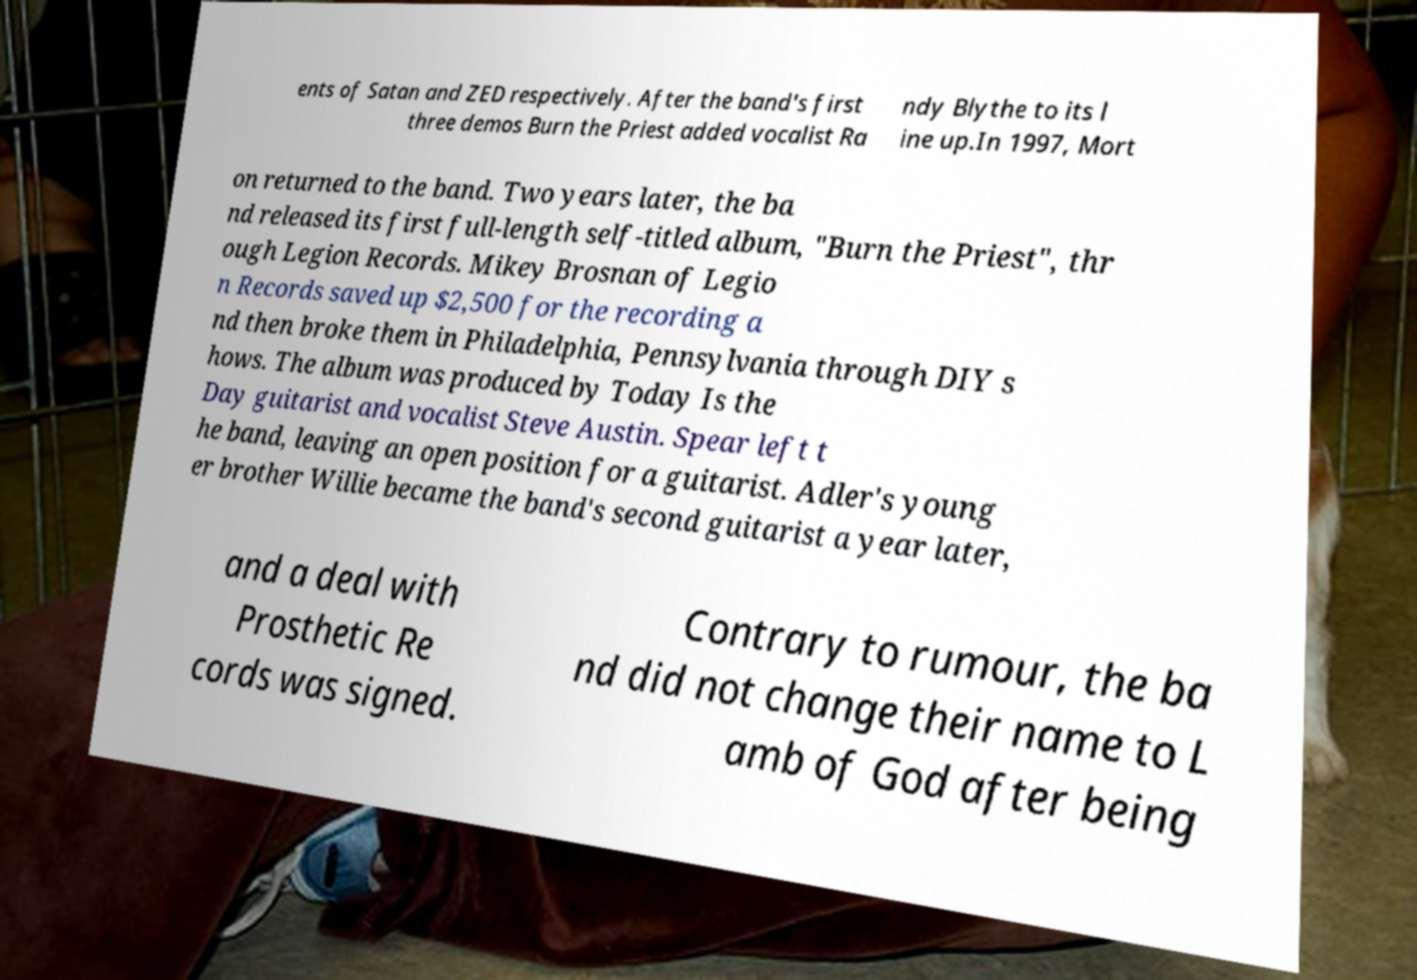Please read and relay the text visible in this image. What does it say? ents of Satan and ZED respectively. After the band's first three demos Burn the Priest added vocalist Ra ndy Blythe to its l ine up.In 1997, Mort on returned to the band. Two years later, the ba nd released its first full-length self-titled album, "Burn the Priest", thr ough Legion Records. Mikey Brosnan of Legio n Records saved up $2,500 for the recording a nd then broke them in Philadelphia, Pennsylvania through DIY s hows. The album was produced by Today Is the Day guitarist and vocalist Steve Austin. Spear left t he band, leaving an open position for a guitarist. Adler's young er brother Willie became the band's second guitarist a year later, and a deal with Prosthetic Re cords was signed. Contrary to rumour, the ba nd did not change their name to L amb of God after being 